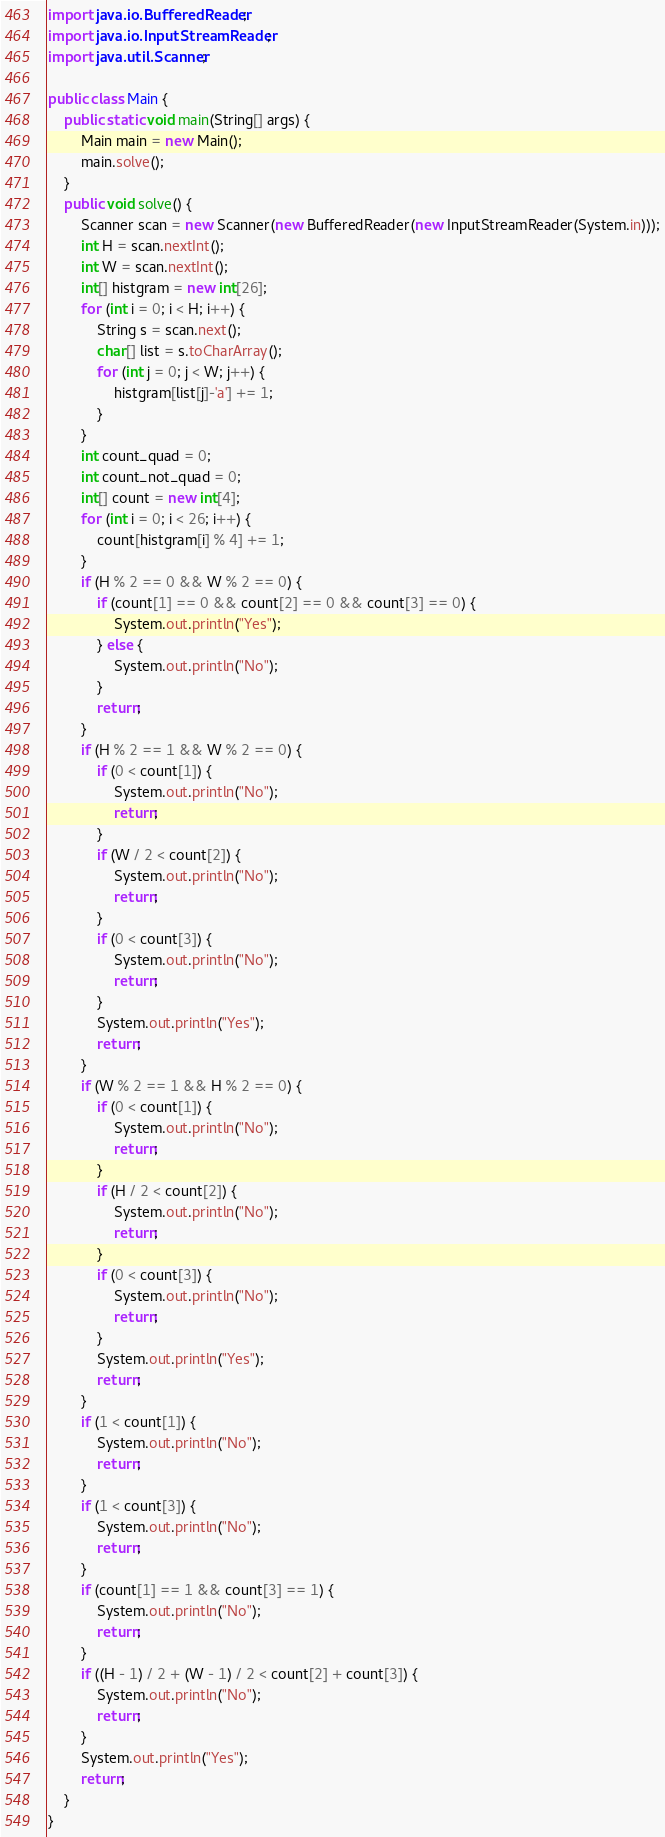Convert code to text. <code><loc_0><loc_0><loc_500><loc_500><_Java_>import java.io.BufferedReader;
import java.io.InputStreamReader;
import java.util.Scanner;

public class Main {
    public static void main(String[] args) {
        Main main = new Main();
        main.solve();
    }
    public void solve() {
        Scanner scan = new Scanner(new BufferedReader(new InputStreamReader(System.in)));
        int H = scan.nextInt();
        int W = scan.nextInt();
        int[] histgram = new int[26];
        for (int i = 0; i < H; i++) {
            String s = scan.next();
            char[] list = s.toCharArray();
            for (int j = 0; j < W; j++) {
                histgram[list[j]-'a'] += 1;
            }
        }
        int count_quad = 0;
        int count_not_quad = 0;
        int[] count = new int[4];
        for (int i = 0; i < 26; i++) {
            count[histgram[i] % 4] += 1;
        }
        if (H % 2 == 0 && W % 2 == 0) {
            if (count[1] == 0 && count[2] == 0 && count[3] == 0) {
                System.out.println("Yes");
            } else {
                System.out.println("No");
            }
            return;
        }
        if (H % 2 == 1 && W % 2 == 0) {
            if (0 < count[1]) {
                System.out.println("No");
                return;
            }
            if (W / 2 < count[2]) {
                System.out.println("No");
                return;
            }
            if (0 < count[3]) {
                System.out.println("No");
                return;
            }
            System.out.println("Yes");
            return;
        }
        if (W % 2 == 1 && H % 2 == 0) {
            if (0 < count[1]) {
                System.out.println("No");
                return;
            }
            if (H / 2 < count[2]) {
                System.out.println("No");
                return;
            }
            if (0 < count[3]) {
                System.out.println("No");
                return;
            }
            System.out.println("Yes");
            return;
        }
        if (1 < count[1]) {
            System.out.println("No");
            return;
        }
        if (1 < count[3]) {
            System.out.println("No");
            return;
        }
        if (count[1] == 1 && count[3] == 1) {
            System.out.println("No");
            return;
        }
        if ((H - 1) / 2 + (W - 1) / 2 < count[2] + count[3]) {
            System.out.println("No");
            return;
        }
        System.out.println("Yes");
        return;
    }
}
</code> 